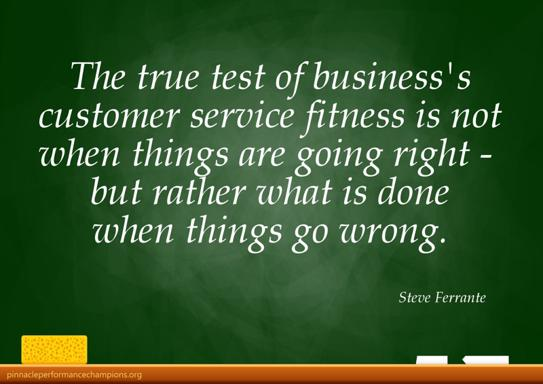What is the main point emphasized in the quote about customer service in the image? The quote by Steve Ferrante on the image emphasizes that a business’s customer service quality is truly tested during tough times, not just when everything is functioning smoothly. It implies that the hallmark of great customer service lies in its ability to effectively resolve issues and adapt to challenges as they arise, thereby maintaining trust and satisfaction among customers. 